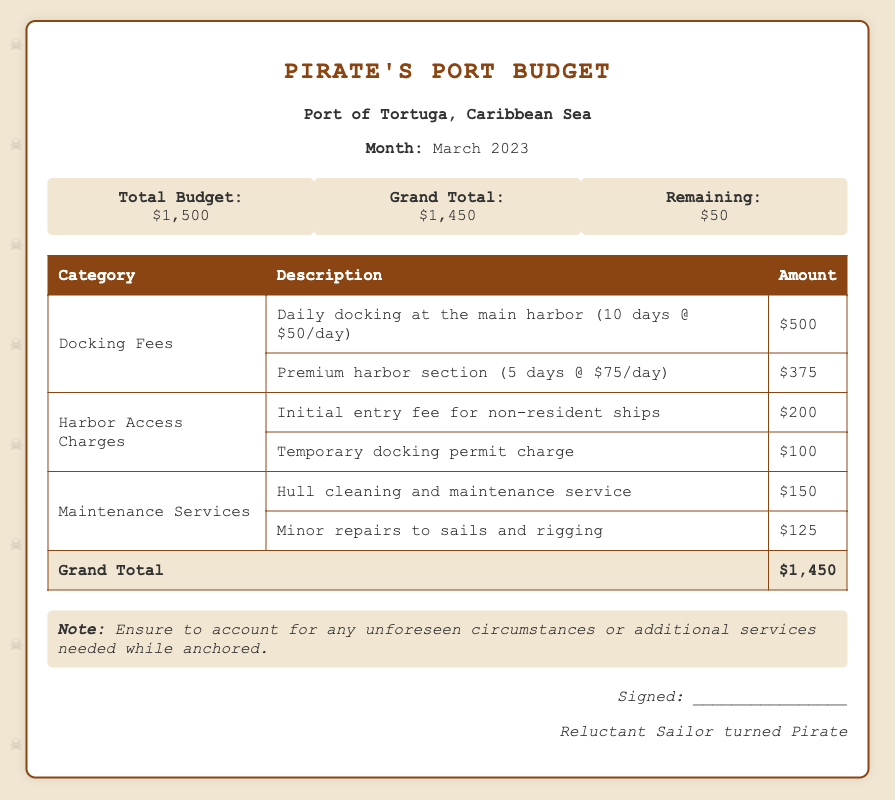What is the total budget? The total budget is explicitly stated in the document and is $1,500.
Answer: $1,500 How much does daily docking cost per day? The document mentions the daily docking rate at the main harbor is $50 per day.
Answer: $50 How many days was the vessel docked in the premium harbor section? The document indicates the vessel was docked in the premium harbor section for 5 days.
Answer: 5 days What is the grand total of all charges? The grand total of all charges is specified in the document as $1,450.
Answer: $1,450 What is the charge for the initial entry fee for non-resident ships? The charge for the initial entry fee for non-resident ships is noted as $200 in the document.
Answer: $200 How much was spent on hull cleaning and maintenance? The document lists the cost for hull cleaning and maintenance service as $150.
Answer: $150 What is the remaining budget after all expenses? The remaining budget, after all expenses, is stated as $50 in the document.
Answer: $50 How many categories are there for fees charged? The document presents fees in three main categories: Docking Fees, Harbor Access Charges, and Maintenance Services, totaling three categories.
Answer: 3 What is the total cost for minor repairs to sails and rigging? The cost for minor repairs to sails and rigging is listed as $125 in the document.
Answer: $125 